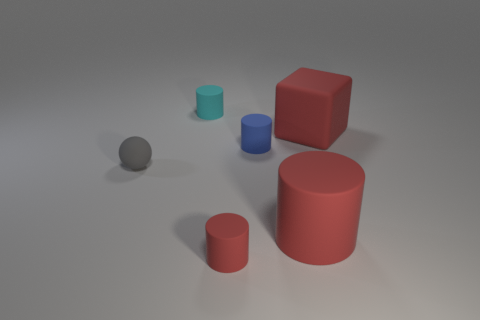Add 1 matte cylinders. How many objects exist? 7 Subtract all cubes. How many objects are left? 5 Add 5 matte cubes. How many matte cubes are left? 6 Add 5 blue things. How many blue things exist? 6 Subtract 0 gray cylinders. How many objects are left? 6 Subtract all tiny purple rubber cylinders. Subtract all gray balls. How many objects are left? 5 